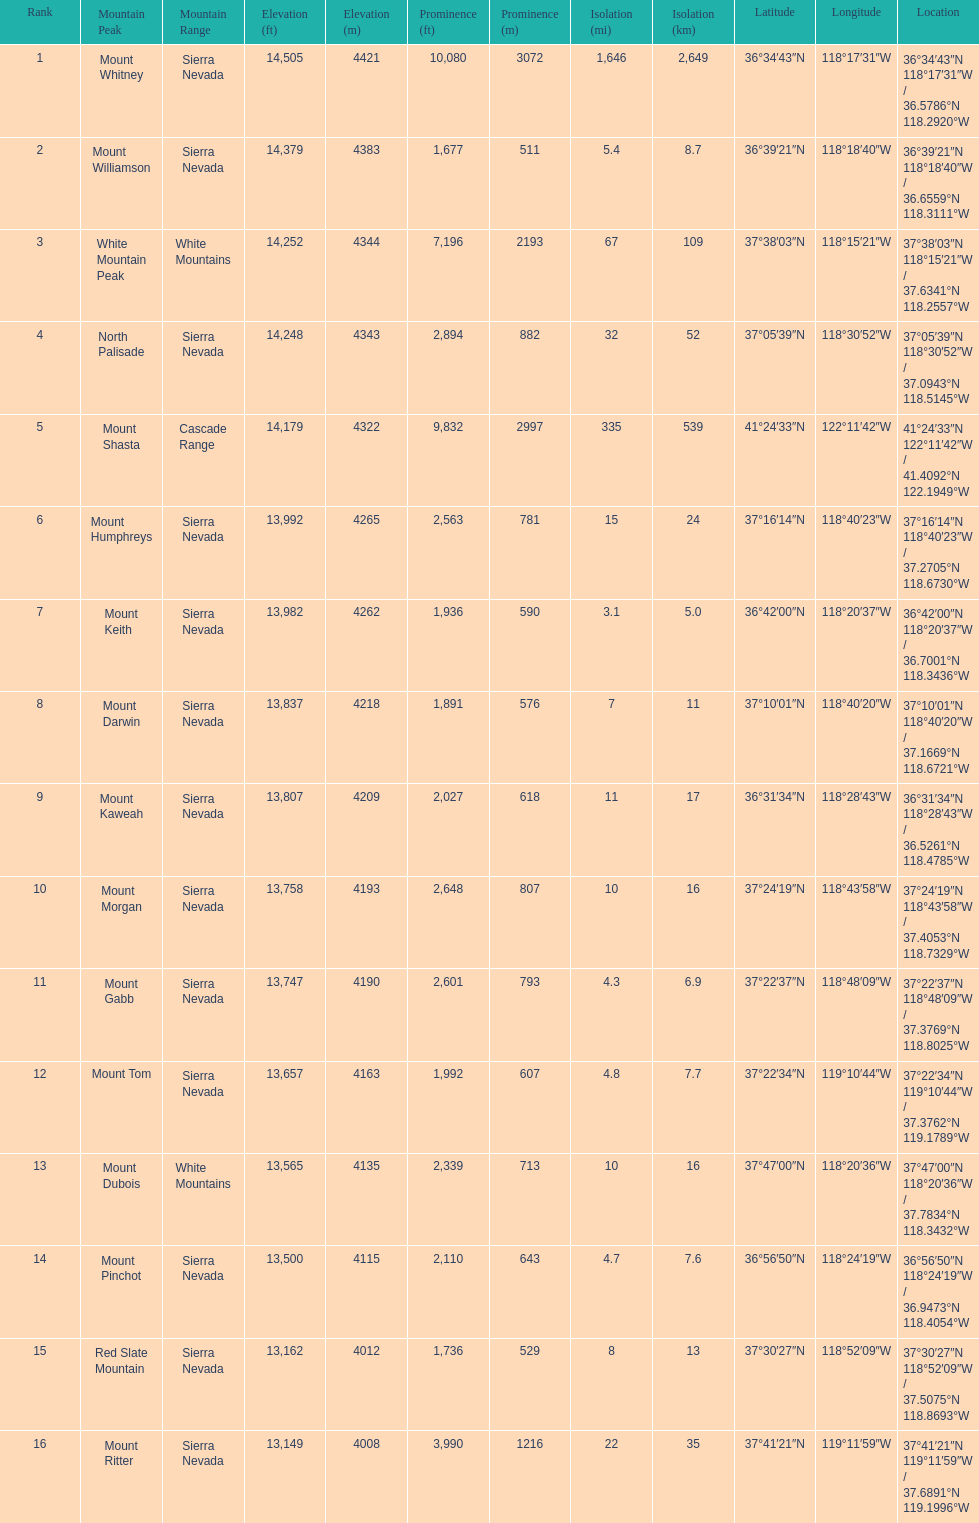Is the peak of mount keith above or below the peak of north palisade? Below. 